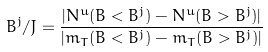<formula> <loc_0><loc_0><loc_500><loc_500>B ^ { j } / J = \frac { | N ^ { u } ( B < B ^ { j } ) - N ^ { u } ( B > B ^ { j } ) | } { | m _ { T } ( B < B ^ { j } ) - m _ { T } ( B > B ^ { j } ) | }</formula> 